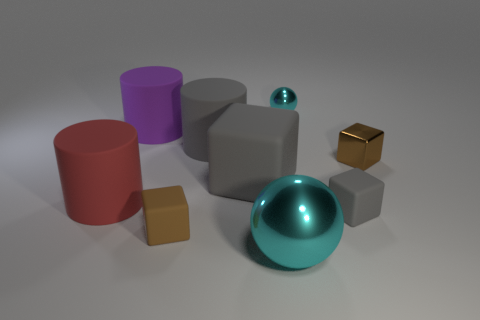Add 1 small yellow blocks. How many objects exist? 10 Subtract all green cylinders. Subtract all brown cubes. How many cylinders are left? 3 Subtract all balls. How many objects are left? 7 Subtract 1 gray cylinders. How many objects are left? 8 Subtract all brown matte things. Subtract all big spheres. How many objects are left? 7 Add 5 small cyan metallic balls. How many small cyan metallic balls are left? 6 Add 8 large red objects. How many large red objects exist? 9 